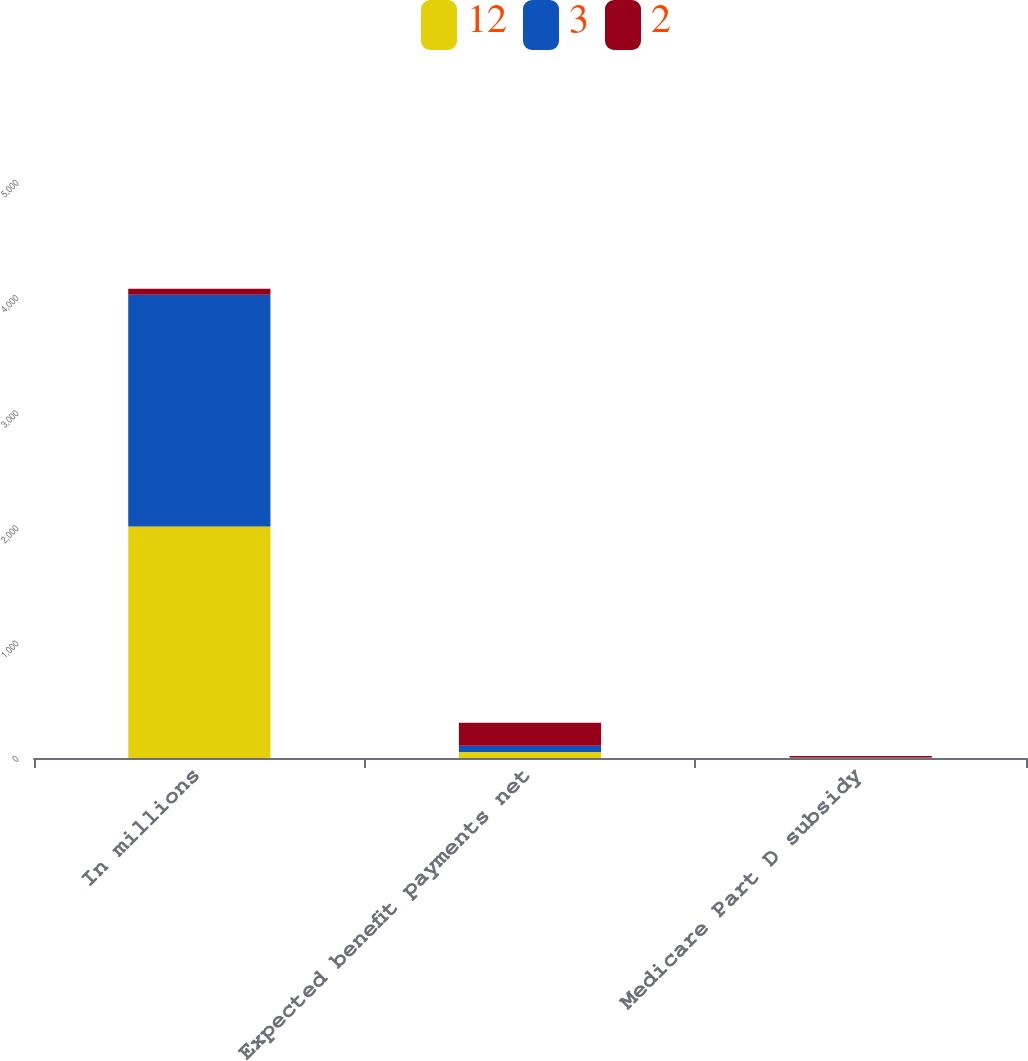Convert chart to OTSL. <chart><loc_0><loc_0><loc_500><loc_500><stacked_bar_chart><ecel><fcel>In millions<fcel>Expected benefit payments net<fcel>Medicare Part D subsidy<nl><fcel>12<fcel>2010<fcel>53<fcel>2<nl><fcel>3<fcel>2011<fcel>53<fcel>3<nl><fcel>2<fcel>53<fcel>199<fcel>12<nl></chart> 